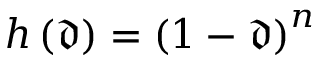Convert formula to latex. <formula><loc_0><loc_0><loc_500><loc_500>h \left ( \mathfrak { d } \right ) = \left ( 1 - \mathfrak { d } \right ) ^ { n }</formula> 